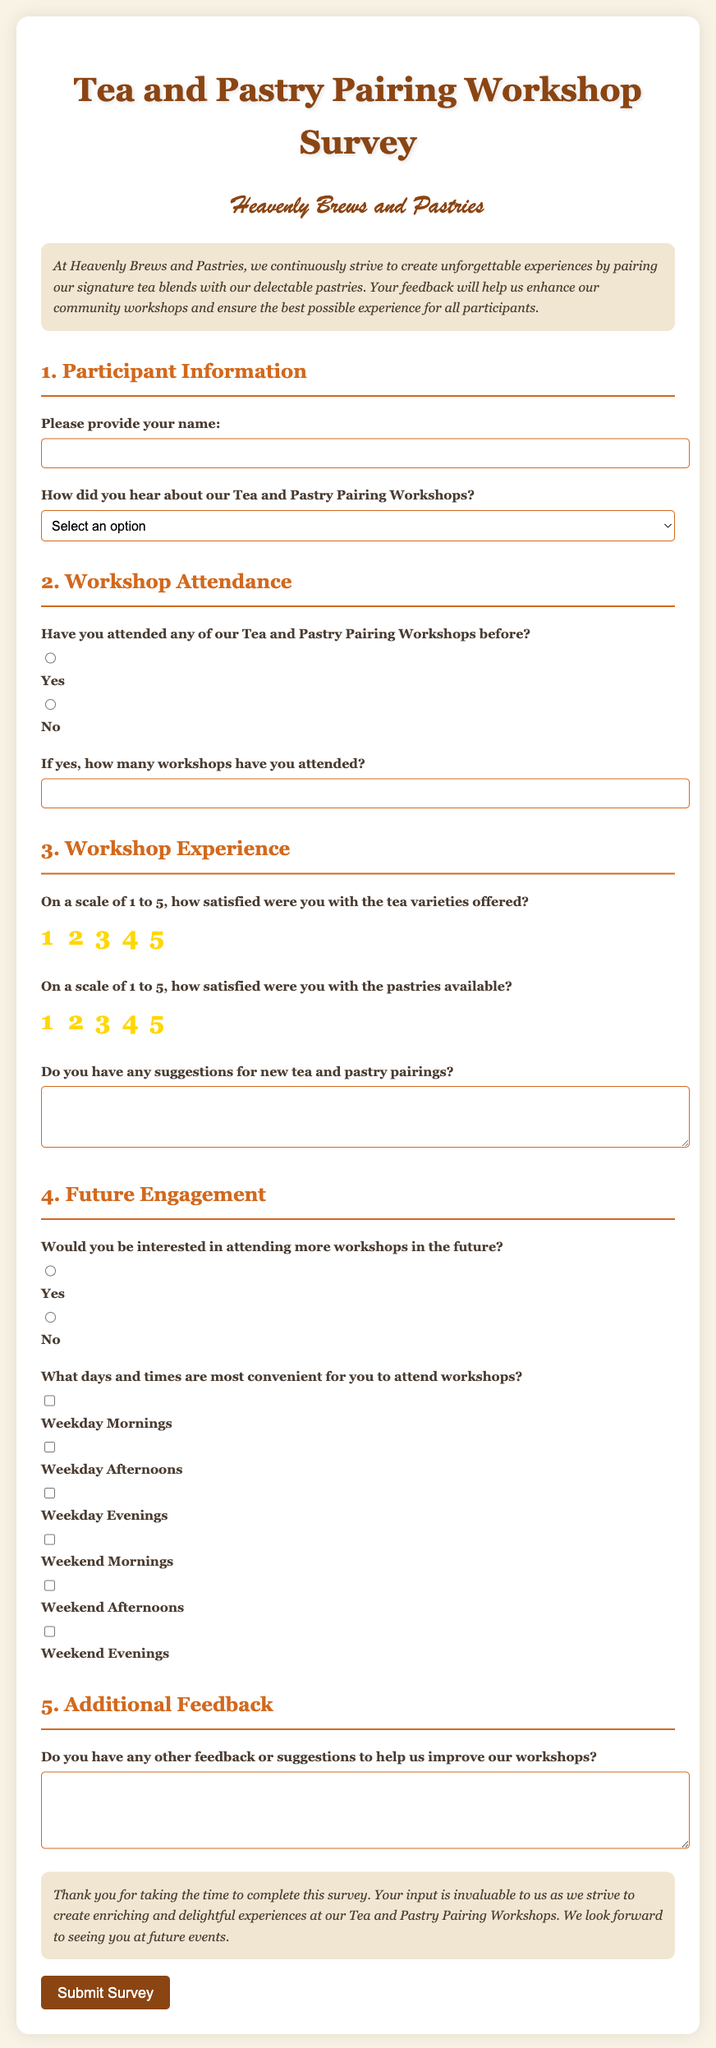What is the title of the survey? The title of the survey is clearly stated at the top of the document.
Answer: Tea and Pastry Pairing Workshop Survey What is the name of the bakery? The name of the bakery is mentioned prominently in the document.
Answer: Heavenly Brews and Pastries What is the main purpose of the survey? The purpose of the survey is described in the introduction section of the document.
Answer: To enhance community workshops and experience How many questions are there in the workshop experience section? The number of questions in the workshop experience section can be counted from the document structure.
Answer: 3 What scale is used to rate the tea satisfaction? The scale for tea satisfaction is indicated within the question about satisfaction levels.
Answer: 1 to 5 What feature allows participants to provide pairing suggestions? The document contains a specific section that enables participants to offer suggestions.
Answer: Textarea for pairing suggestions How can participants indicate their interest in future workshops? Participants can respond to their future interest using radio buttons in the document.
Answer: Yes or No What types of convenient times are offered for future workshops? The document lists various options that participants can choose as convenient times.
Answer: Weekday Mornings, Weekday Afternoons, Weekday Evenings, Weekend Mornings, Weekend Afternoons, Weekend Evenings What type of feedback is solicited in the additional feedback section? The document asks for unspecified comments or suggestions for improvement in this section.
Answer: General feedback or suggestions 